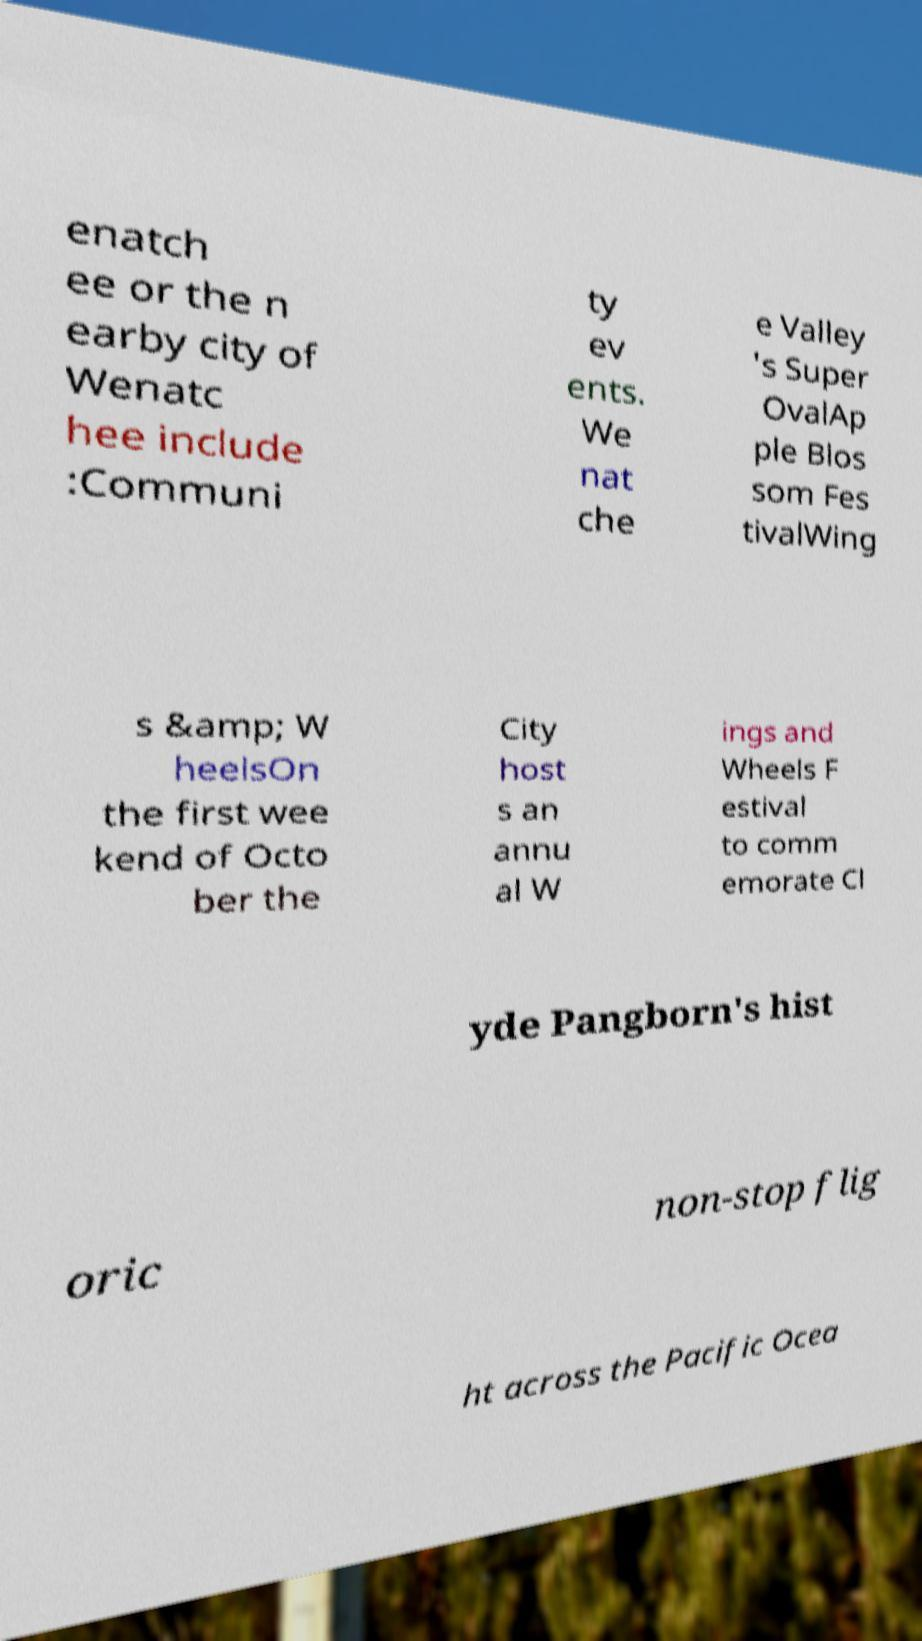I need the written content from this picture converted into text. Can you do that? enatch ee or the n earby city of Wenatc hee include :Communi ty ev ents. We nat che e Valley 's Super OvalAp ple Blos som Fes tivalWing s &amp; W heelsOn the first wee kend of Octo ber the City host s an annu al W ings and Wheels F estival to comm emorate Cl yde Pangborn's hist oric non-stop flig ht across the Pacific Ocea 